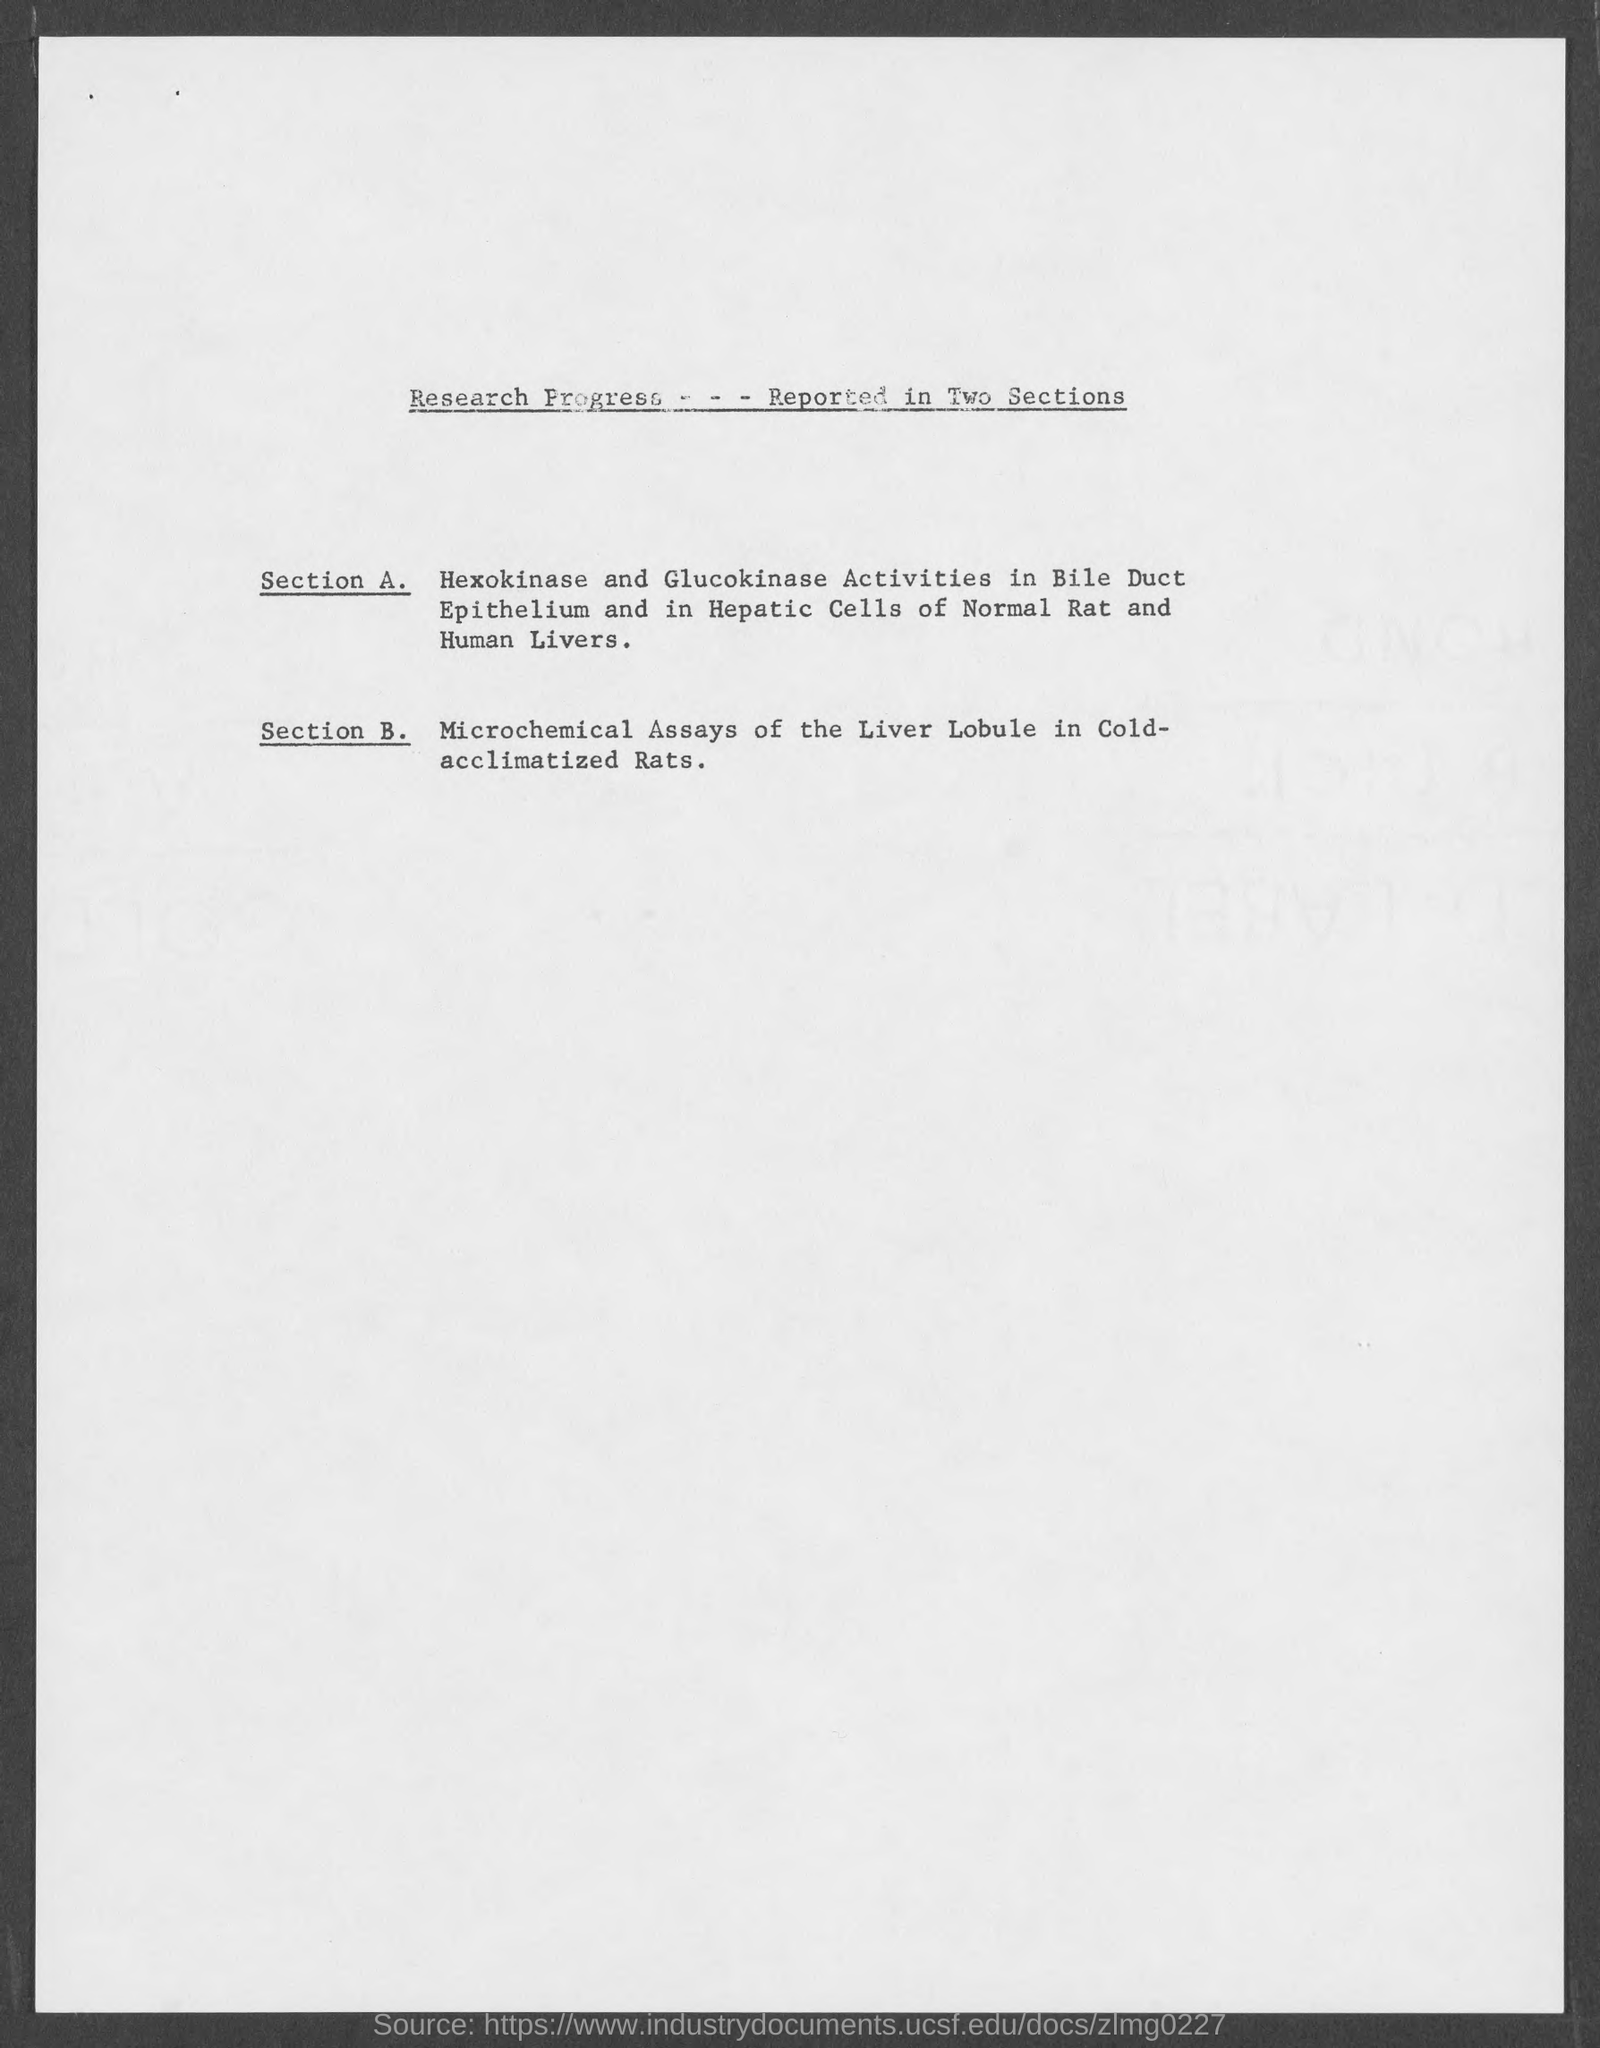What does Section B. deal with?
Give a very brief answer. Microchemical assays of the liver lobule in cold-acclimatized rats. 